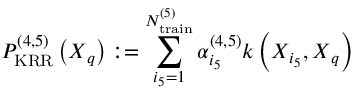<formula> <loc_0><loc_0><loc_500><loc_500>P _ { K R R } ^ { ( 4 , 5 ) } \left ( X _ { q } \right ) \colon = \sum _ { i _ { 5 } = 1 } ^ { N _ { t r a i n } ^ { ( 5 ) } } \alpha _ { i _ { 5 } } ^ { ( 4 , 5 ) } k \left ( X _ { i _ { 5 } } , X _ { q } \right )</formula> 